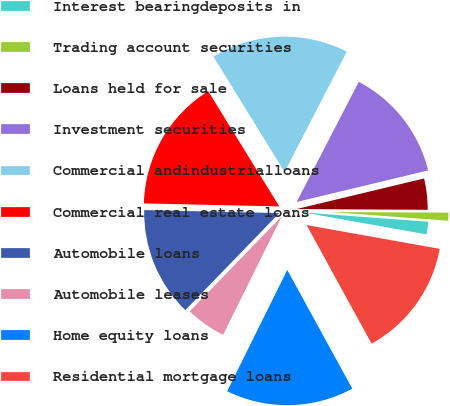<chart> <loc_0><loc_0><loc_500><loc_500><pie_chart><fcel>Interest bearingdeposits in<fcel>Trading account securities<fcel>Loans held for sale<fcel>Investment securities<fcel>Commercial andindustrialloans<fcel>Commercial real estate loans<fcel>Automobile loans<fcel>Automobile leases<fcel>Home equity loans<fcel>Residential mortgage loans<nl><fcel>1.64%<fcel>1.09%<fcel>3.83%<fcel>13.66%<fcel>16.39%<fcel>15.85%<fcel>13.11%<fcel>4.92%<fcel>15.3%<fcel>14.21%<nl></chart> 